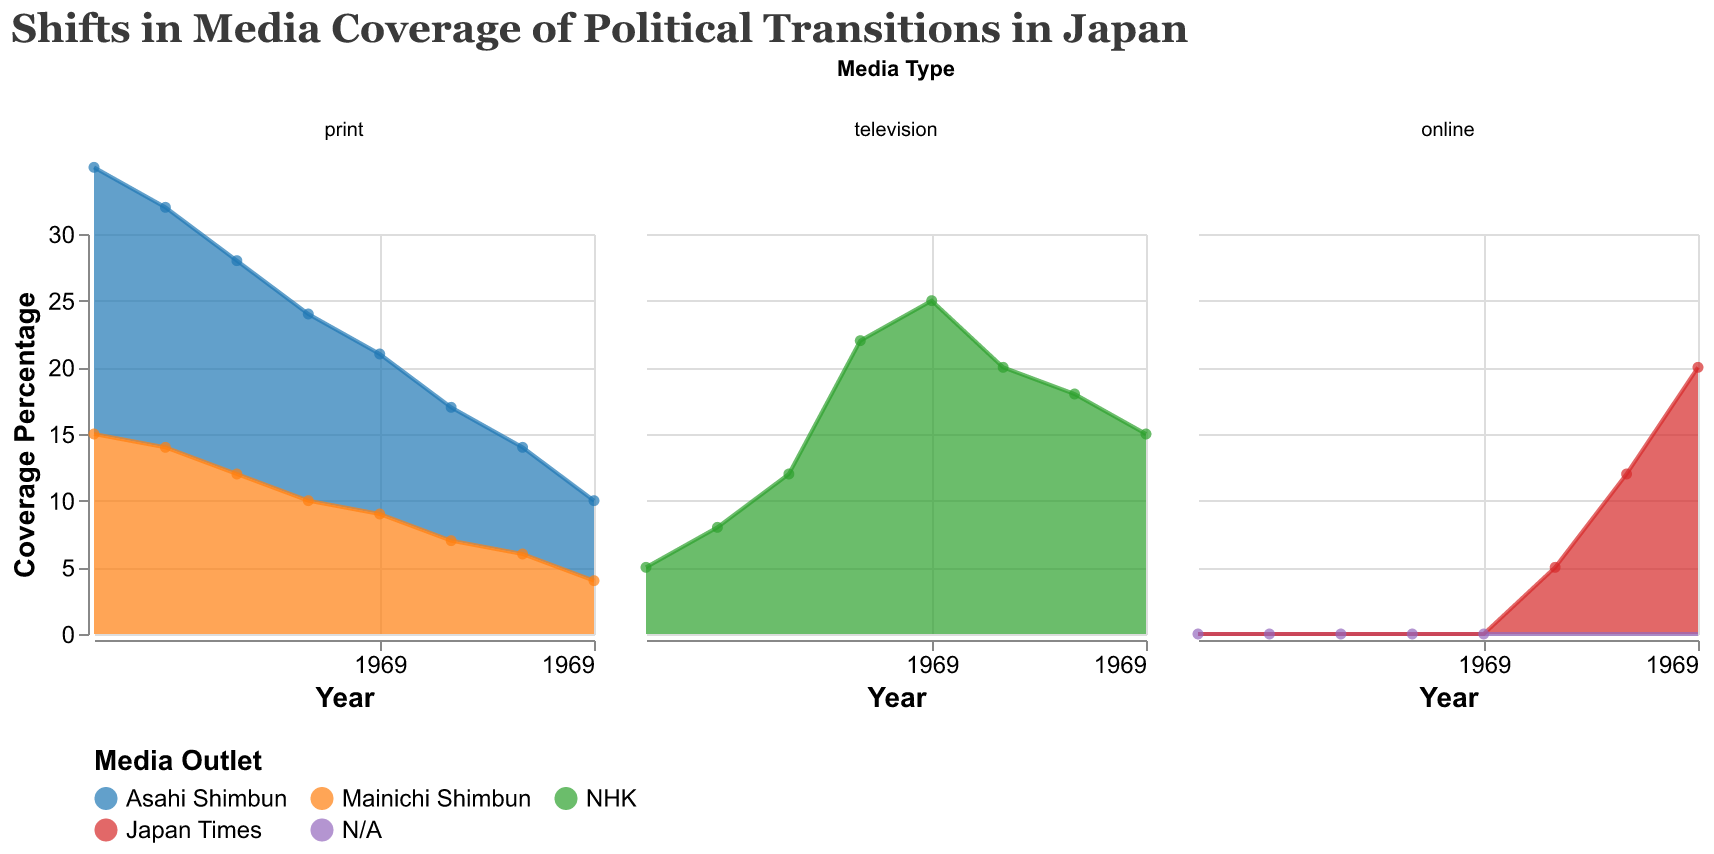What is the title of the figure? The title is typically located at the top of the figure, which in this case reads "Shifts in Media Coverage of Political Transitions in Japan".
Answer: Shifts in Media Coverage of Political Transitions in Japan Which media type had no data points in 1950? The "online" media type had a coverage percentage of 0 in 1950, as indicated in the relevant subplot.
Answer: Online In which year did NHK have the highest coverage percentage and what was it? By observing the television subplot, NHK's coverage percentage peaked in 1990 with a value of 25%.
Answer: 1990, 25% How did the coverage percentage of Asahi Shimbun change from 1950 to 2020? In the print subplot, Asahi Shimbun's coverage percentage decreased from 20% in 1950 to 6% in 2020.
Answer: Decreased from 20% to 6% Which medium's coverage grew the most from 2000 to 2020? In the online subplot, Japan Times' coverage increased from 5% in 2000 to 20% in 2020, showing the most significant growth among all mediums in this timeframe.
Answer: Online, Japan Times Comparing print media, which outlet had a lower coverage percentage in 1970? In the print subplot for 1970, Mainichi Shimbun had a lower coverage percentage (12%) compared to Asahi Shimbun (16%).
Answer: Mainichi Shimbun What was the combined coverage percentage for NHK and Mainichi Shimbun in 1980? In 1980, NHK had a coverage percentage of 22% and Mainichi Shimbun had 10%; summing these values gives a combined coverage percentage of 32%.
Answer: 32% Which media type showed a general upward trend from 2000 to 2020? The online media subplot shows a clear increase in coverage percentage from 2000 (5%) to 2020 (20%), indicating an upward trend.
Answer: Online What can be inferred about the trend in televised media coverage from 1980 to 2020? Analyzing the television subplot, one sees that NHK's coverage percentage reached a peak in 1990 (25%) and displayed a general downward trend thereafter, declining to 15% in 2020.
Answer: General downward trend 